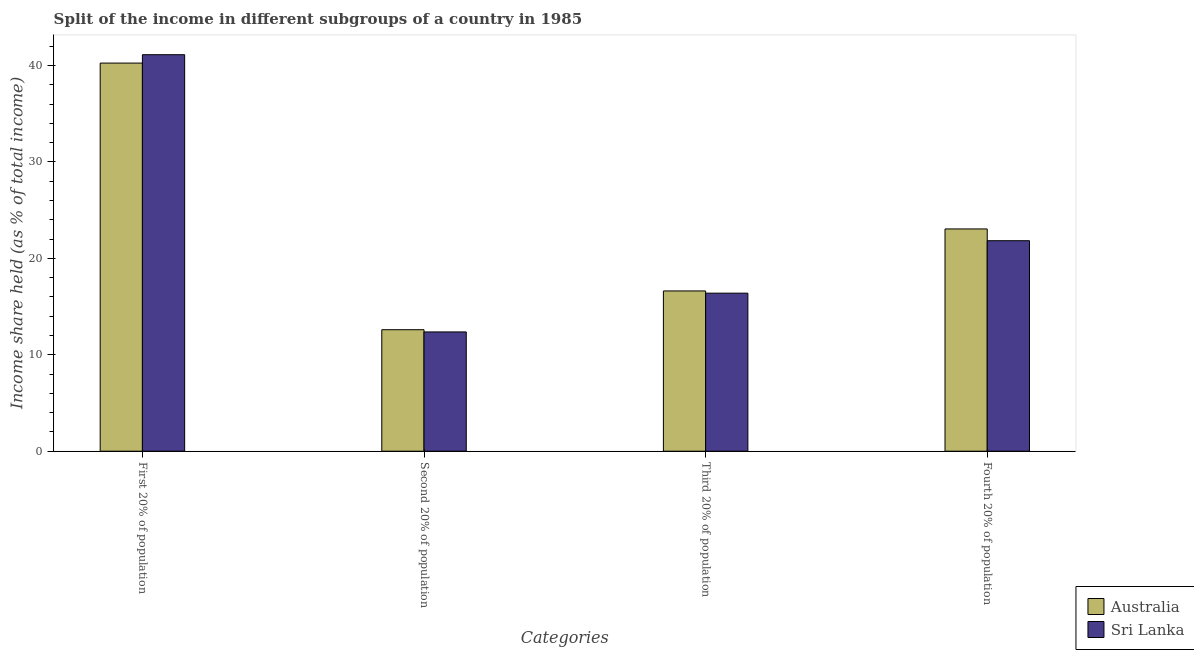Are the number of bars on each tick of the X-axis equal?
Offer a very short reply. Yes. How many bars are there on the 4th tick from the right?
Offer a very short reply. 2. What is the label of the 3rd group of bars from the left?
Keep it short and to the point. Third 20% of population. What is the share of the income held by fourth 20% of the population in Australia?
Provide a succinct answer. 23.05. Across all countries, what is the maximum share of the income held by second 20% of the population?
Offer a very short reply. 12.6. Across all countries, what is the minimum share of the income held by second 20% of the population?
Ensure brevity in your answer.  12.37. In which country was the share of the income held by first 20% of the population minimum?
Your answer should be compact. Australia. What is the total share of the income held by second 20% of the population in the graph?
Your response must be concise. 24.97. What is the difference between the share of the income held by third 20% of the population in Australia and that in Sri Lanka?
Offer a very short reply. 0.23. What is the difference between the share of the income held by first 20% of the population in Sri Lanka and the share of the income held by third 20% of the population in Australia?
Offer a very short reply. 24.5. What is the average share of the income held by third 20% of the population per country?
Make the answer very short. 16.51. What is the difference between the share of the income held by third 20% of the population and share of the income held by fourth 20% of the population in Australia?
Your response must be concise. -6.43. In how many countries, is the share of the income held by first 20% of the population greater than 12 %?
Ensure brevity in your answer.  2. What is the ratio of the share of the income held by second 20% of the population in Sri Lanka to that in Australia?
Give a very brief answer. 0.98. What is the difference between the highest and the second highest share of the income held by second 20% of the population?
Offer a terse response. 0.23. What is the difference between the highest and the lowest share of the income held by third 20% of the population?
Your answer should be very brief. 0.23. In how many countries, is the share of the income held by second 20% of the population greater than the average share of the income held by second 20% of the population taken over all countries?
Make the answer very short. 1. Is the sum of the share of the income held by fourth 20% of the population in Sri Lanka and Australia greater than the maximum share of the income held by second 20% of the population across all countries?
Make the answer very short. Yes. Is it the case that in every country, the sum of the share of the income held by third 20% of the population and share of the income held by fourth 20% of the population is greater than the sum of share of the income held by second 20% of the population and share of the income held by first 20% of the population?
Your response must be concise. Yes. What does the 2nd bar from the left in Third 20% of population represents?
Your answer should be compact. Sri Lanka. What does the 1st bar from the right in Fourth 20% of population represents?
Ensure brevity in your answer.  Sri Lanka. Is it the case that in every country, the sum of the share of the income held by first 20% of the population and share of the income held by second 20% of the population is greater than the share of the income held by third 20% of the population?
Make the answer very short. Yes. How many bars are there?
Provide a succinct answer. 8. What is the difference between two consecutive major ticks on the Y-axis?
Make the answer very short. 10. Are the values on the major ticks of Y-axis written in scientific E-notation?
Offer a very short reply. No. Does the graph contain any zero values?
Keep it short and to the point. No. Does the graph contain grids?
Your answer should be very brief. No. How many legend labels are there?
Your response must be concise. 2. How are the legend labels stacked?
Offer a terse response. Vertical. What is the title of the graph?
Ensure brevity in your answer.  Split of the income in different subgroups of a country in 1985. What is the label or title of the X-axis?
Offer a terse response. Categories. What is the label or title of the Y-axis?
Your answer should be compact. Income share held (as % of total income). What is the Income share held (as % of total income) of Australia in First 20% of population?
Ensure brevity in your answer.  40.25. What is the Income share held (as % of total income) in Sri Lanka in First 20% of population?
Provide a succinct answer. 41.12. What is the Income share held (as % of total income) in Australia in Second 20% of population?
Provide a short and direct response. 12.6. What is the Income share held (as % of total income) in Sri Lanka in Second 20% of population?
Your answer should be compact. 12.37. What is the Income share held (as % of total income) in Australia in Third 20% of population?
Ensure brevity in your answer.  16.62. What is the Income share held (as % of total income) of Sri Lanka in Third 20% of population?
Provide a short and direct response. 16.39. What is the Income share held (as % of total income) in Australia in Fourth 20% of population?
Your response must be concise. 23.05. What is the Income share held (as % of total income) in Sri Lanka in Fourth 20% of population?
Provide a succinct answer. 21.83. Across all Categories, what is the maximum Income share held (as % of total income) in Australia?
Ensure brevity in your answer.  40.25. Across all Categories, what is the maximum Income share held (as % of total income) of Sri Lanka?
Keep it short and to the point. 41.12. Across all Categories, what is the minimum Income share held (as % of total income) in Australia?
Your answer should be very brief. 12.6. Across all Categories, what is the minimum Income share held (as % of total income) of Sri Lanka?
Offer a terse response. 12.37. What is the total Income share held (as % of total income) in Australia in the graph?
Give a very brief answer. 92.52. What is the total Income share held (as % of total income) in Sri Lanka in the graph?
Your answer should be compact. 91.71. What is the difference between the Income share held (as % of total income) of Australia in First 20% of population and that in Second 20% of population?
Give a very brief answer. 27.65. What is the difference between the Income share held (as % of total income) of Sri Lanka in First 20% of population and that in Second 20% of population?
Ensure brevity in your answer.  28.75. What is the difference between the Income share held (as % of total income) in Australia in First 20% of population and that in Third 20% of population?
Provide a succinct answer. 23.63. What is the difference between the Income share held (as % of total income) of Sri Lanka in First 20% of population and that in Third 20% of population?
Make the answer very short. 24.73. What is the difference between the Income share held (as % of total income) in Sri Lanka in First 20% of population and that in Fourth 20% of population?
Ensure brevity in your answer.  19.29. What is the difference between the Income share held (as % of total income) in Australia in Second 20% of population and that in Third 20% of population?
Your answer should be compact. -4.02. What is the difference between the Income share held (as % of total income) in Sri Lanka in Second 20% of population and that in Third 20% of population?
Make the answer very short. -4.02. What is the difference between the Income share held (as % of total income) in Australia in Second 20% of population and that in Fourth 20% of population?
Ensure brevity in your answer.  -10.45. What is the difference between the Income share held (as % of total income) in Sri Lanka in Second 20% of population and that in Fourth 20% of population?
Offer a terse response. -9.46. What is the difference between the Income share held (as % of total income) in Australia in Third 20% of population and that in Fourth 20% of population?
Keep it short and to the point. -6.43. What is the difference between the Income share held (as % of total income) in Sri Lanka in Third 20% of population and that in Fourth 20% of population?
Provide a short and direct response. -5.44. What is the difference between the Income share held (as % of total income) of Australia in First 20% of population and the Income share held (as % of total income) of Sri Lanka in Second 20% of population?
Keep it short and to the point. 27.88. What is the difference between the Income share held (as % of total income) in Australia in First 20% of population and the Income share held (as % of total income) in Sri Lanka in Third 20% of population?
Give a very brief answer. 23.86. What is the difference between the Income share held (as % of total income) in Australia in First 20% of population and the Income share held (as % of total income) in Sri Lanka in Fourth 20% of population?
Offer a terse response. 18.42. What is the difference between the Income share held (as % of total income) of Australia in Second 20% of population and the Income share held (as % of total income) of Sri Lanka in Third 20% of population?
Ensure brevity in your answer.  -3.79. What is the difference between the Income share held (as % of total income) in Australia in Second 20% of population and the Income share held (as % of total income) in Sri Lanka in Fourth 20% of population?
Provide a succinct answer. -9.23. What is the difference between the Income share held (as % of total income) of Australia in Third 20% of population and the Income share held (as % of total income) of Sri Lanka in Fourth 20% of population?
Offer a terse response. -5.21. What is the average Income share held (as % of total income) of Australia per Categories?
Provide a succinct answer. 23.13. What is the average Income share held (as % of total income) of Sri Lanka per Categories?
Provide a short and direct response. 22.93. What is the difference between the Income share held (as % of total income) in Australia and Income share held (as % of total income) in Sri Lanka in First 20% of population?
Give a very brief answer. -0.87. What is the difference between the Income share held (as % of total income) of Australia and Income share held (as % of total income) of Sri Lanka in Second 20% of population?
Offer a terse response. 0.23. What is the difference between the Income share held (as % of total income) in Australia and Income share held (as % of total income) in Sri Lanka in Third 20% of population?
Offer a very short reply. 0.23. What is the difference between the Income share held (as % of total income) of Australia and Income share held (as % of total income) of Sri Lanka in Fourth 20% of population?
Make the answer very short. 1.22. What is the ratio of the Income share held (as % of total income) of Australia in First 20% of population to that in Second 20% of population?
Your response must be concise. 3.19. What is the ratio of the Income share held (as % of total income) of Sri Lanka in First 20% of population to that in Second 20% of population?
Give a very brief answer. 3.32. What is the ratio of the Income share held (as % of total income) in Australia in First 20% of population to that in Third 20% of population?
Ensure brevity in your answer.  2.42. What is the ratio of the Income share held (as % of total income) in Sri Lanka in First 20% of population to that in Third 20% of population?
Provide a succinct answer. 2.51. What is the ratio of the Income share held (as % of total income) of Australia in First 20% of population to that in Fourth 20% of population?
Ensure brevity in your answer.  1.75. What is the ratio of the Income share held (as % of total income) of Sri Lanka in First 20% of population to that in Fourth 20% of population?
Give a very brief answer. 1.88. What is the ratio of the Income share held (as % of total income) in Australia in Second 20% of population to that in Third 20% of population?
Your answer should be compact. 0.76. What is the ratio of the Income share held (as % of total income) of Sri Lanka in Second 20% of population to that in Third 20% of population?
Your answer should be compact. 0.75. What is the ratio of the Income share held (as % of total income) of Australia in Second 20% of population to that in Fourth 20% of population?
Your response must be concise. 0.55. What is the ratio of the Income share held (as % of total income) of Sri Lanka in Second 20% of population to that in Fourth 20% of population?
Your response must be concise. 0.57. What is the ratio of the Income share held (as % of total income) of Australia in Third 20% of population to that in Fourth 20% of population?
Ensure brevity in your answer.  0.72. What is the ratio of the Income share held (as % of total income) of Sri Lanka in Third 20% of population to that in Fourth 20% of population?
Make the answer very short. 0.75. What is the difference between the highest and the second highest Income share held (as % of total income) in Sri Lanka?
Offer a very short reply. 19.29. What is the difference between the highest and the lowest Income share held (as % of total income) of Australia?
Make the answer very short. 27.65. What is the difference between the highest and the lowest Income share held (as % of total income) of Sri Lanka?
Give a very brief answer. 28.75. 